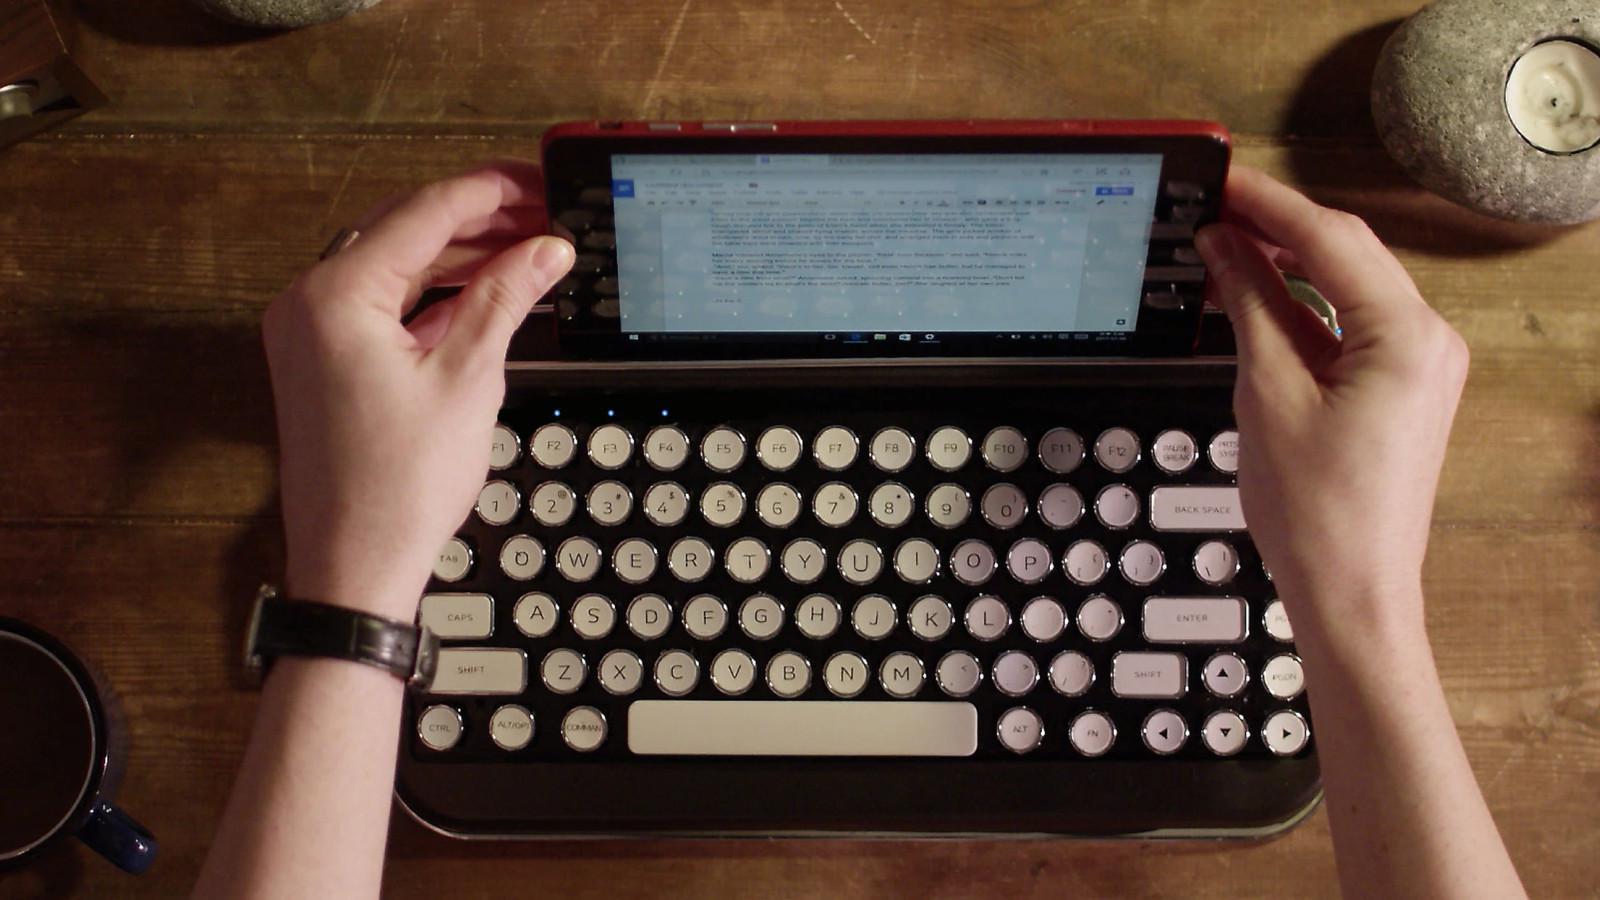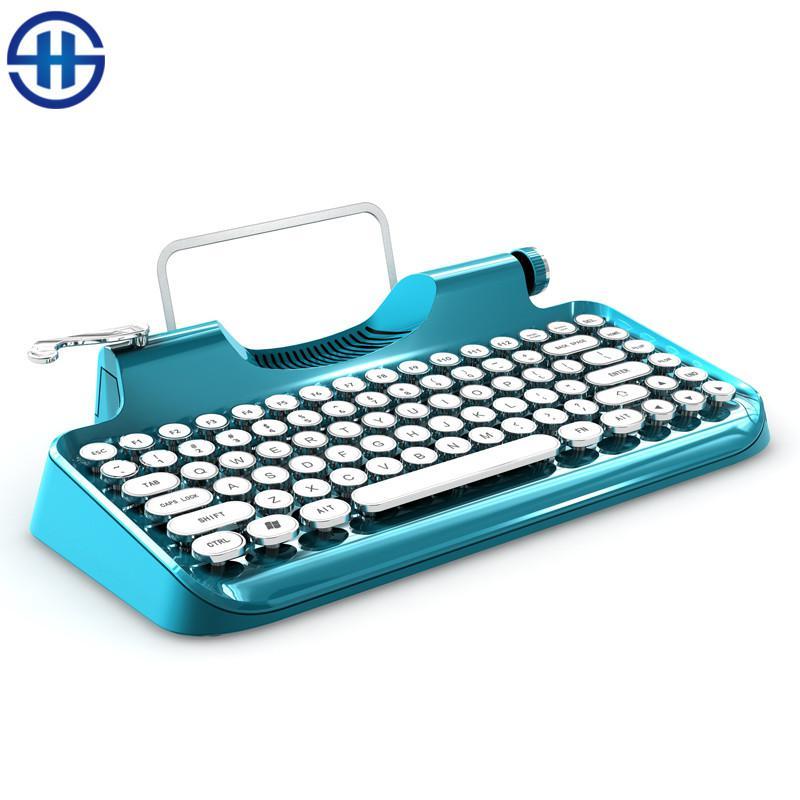The first image is the image on the left, the second image is the image on the right. Examine the images to the left and right. Is the description "One image includes a pair of human hands with one typewriter device." accurate? Answer yes or no. Yes. The first image is the image on the left, the second image is the image on the right. For the images shown, is this caption "One photo includes a pair of human hands." true? Answer yes or no. Yes. 